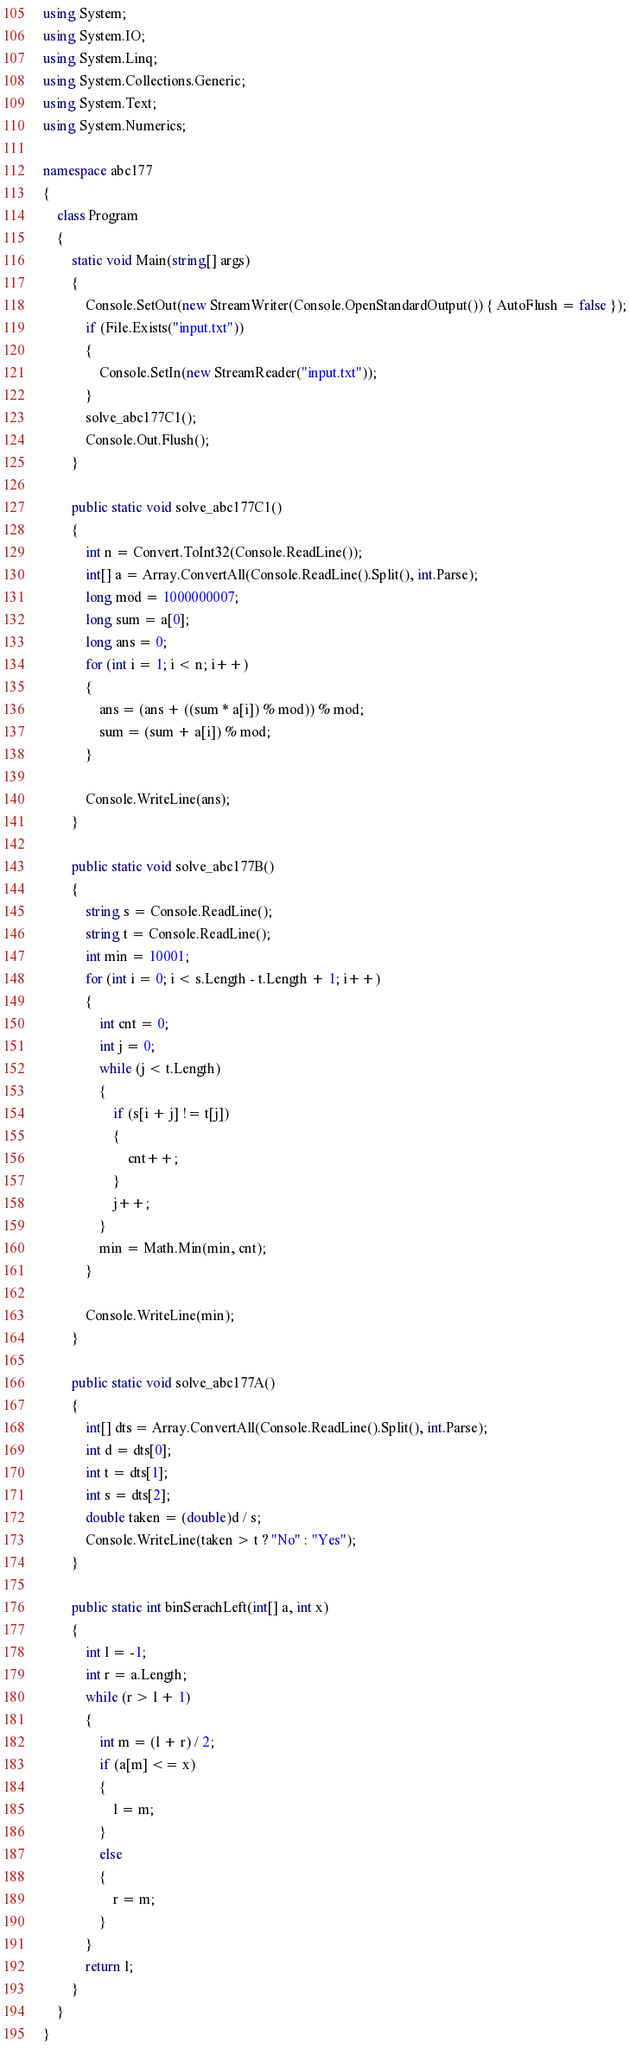<code> <loc_0><loc_0><loc_500><loc_500><_C#_>using System;
using System.IO;
using System.Linq;
using System.Collections.Generic;
using System.Text;
using System.Numerics;

namespace abc177
{
    class Program
    {
        static void Main(string[] args)
        {
            Console.SetOut(new StreamWriter(Console.OpenStandardOutput()) { AutoFlush = false });
            if (File.Exists("input.txt"))
            {
                Console.SetIn(new StreamReader("input.txt"));
            }
            solve_abc177C1();
            Console.Out.Flush();
        }

        public static void solve_abc177C1()
        {
            int n = Convert.ToInt32(Console.ReadLine());
            int[] a = Array.ConvertAll(Console.ReadLine().Split(), int.Parse);
            long mod = 1000000007;
            long sum = a[0];
            long ans = 0;
            for (int i = 1; i < n; i++)
            {
                ans = (ans + ((sum * a[i]) % mod)) % mod;
                sum = (sum + a[i]) % mod;
            }

            Console.WriteLine(ans);
        }

        public static void solve_abc177B()
        {
            string s = Console.ReadLine();
            string t = Console.ReadLine();
            int min = 10001;
            for (int i = 0; i < s.Length - t.Length + 1; i++)
            {
                int cnt = 0;
                int j = 0;
                while (j < t.Length)
                {
                    if (s[i + j] != t[j])
                    {
                        cnt++;
                    }
                    j++;
                }
                min = Math.Min(min, cnt);
            }

            Console.WriteLine(min);
        }

        public static void solve_abc177A()
        {
            int[] dts = Array.ConvertAll(Console.ReadLine().Split(), int.Parse);
            int d = dts[0];
            int t = dts[1];
            int s = dts[2];
            double taken = (double)d / s;
            Console.WriteLine(taken > t ? "No" : "Yes");
        }

        public static int binSerachLeft(int[] a, int x)
        {
            int l = -1;
            int r = a.Length;
            while (r > l + 1)
            {
                int m = (l + r) / 2;
                if (a[m] <= x)
                {
                    l = m;
                }
                else
                {
                    r = m;
                }
            }
            return l;
        }
    }
}</code> 